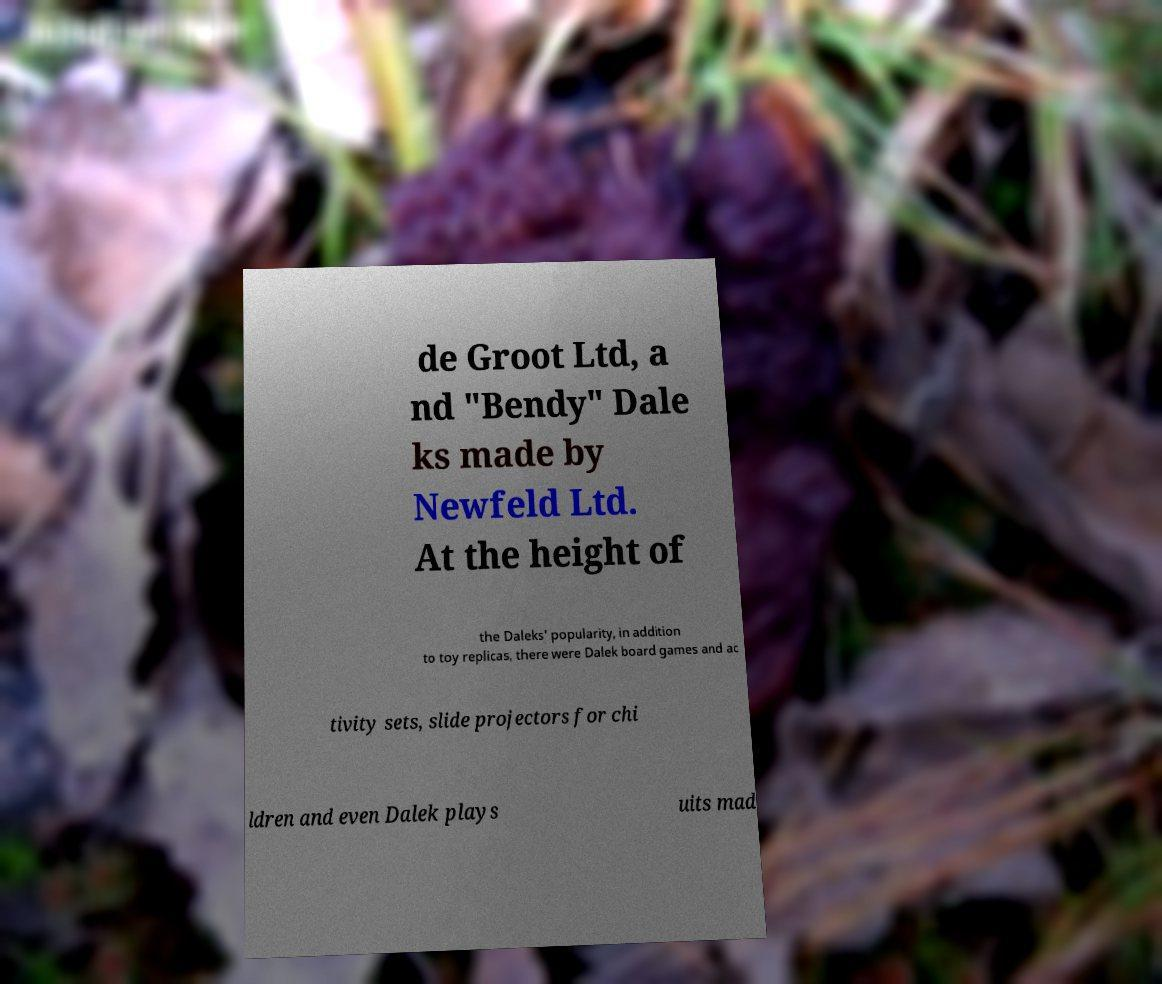I need the written content from this picture converted into text. Can you do that? de Groot Ltd, a nd "Bendy" Dale ks made by Newfeld Ltd. At the height of the Daleks' popularity, in addition to toy replicas, there were Dalek board games and ac tivity sets, slide projectors for chi ldren and even Dalek plays uits mad 